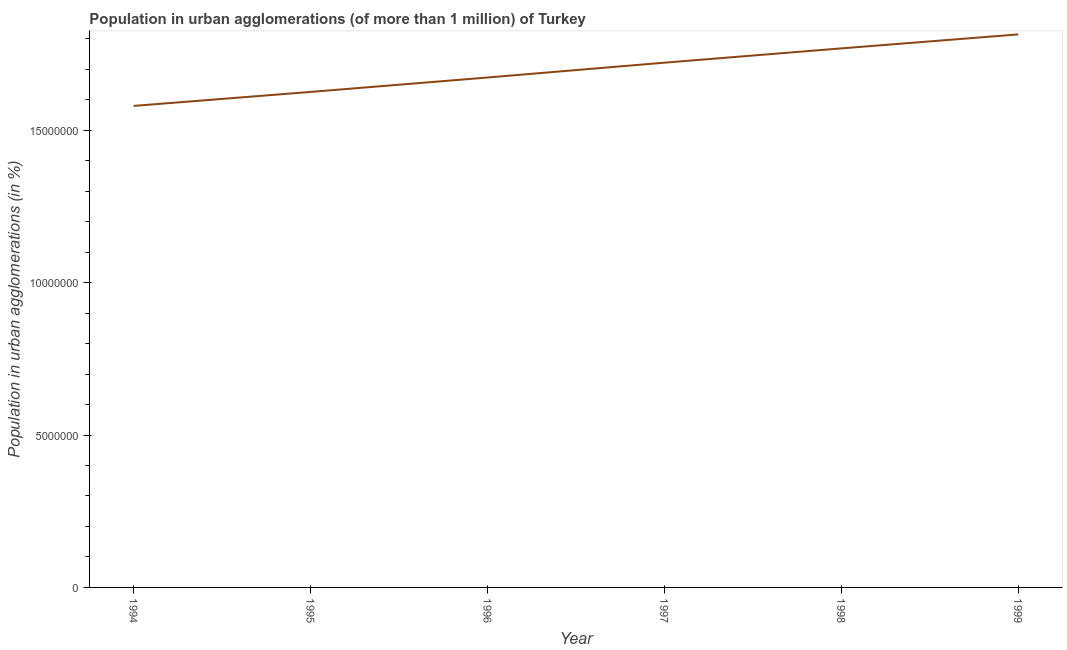What is the population in urban agglomerations in 1994?
Make the answer very short. 1.58e+07. Across all years, what is the maximum population in urban agglomerations?
Make the answer very short. 1.81e+07. Across all years, what is the minimum population in urban agglomerations?
Offer a very short reply. 1.58e+07. In which year was the population in urban agglomerations maximum?
Keep it short and to the point. 1999. What is the sum of the population in urban agglomerations?
Provide a succinct answer. 1.02e+08. What is the difference between the population in urban agglomerations in 1998 and 1999?
Your response must be concise. -4.59e+05. What is the average population in urban agglomerations per year?
Keep it short and to the point. 1.70e+07. What is the median population in urban agglomerations?
Provide a succinct answer. 1.70e+07. Do a majority of the years between 1999 and 1994 (inclusive) have population in urban agglomerations greater than 9000000 %?
Make the answer very short. Yes. What is the ratio of the population in urban agglomerations in 1997 to that in 1999?
Offer a terse response. 0.95. Is the difference between the population in urban agglomerations in 1995 and 1999 greater than the difference between any two years?
Give a very brief answer. No. What is the difference between the highest and the second highest population in urban agglomerations?
Give a very brief answer. 4.59e+05. Is the sum of the population in urban agglomerations in 1996 and 1998 greater than the maximum population in urban agglomerations across all years?
Make the answer very short. Yes. What is the difference between the highest and the lowest population in urban agglomerations?
Your answer should be compact. 2.35e+06. In how many years, is the population in urban agglomerations greater than the average population in urban agglomerations taken over all years?
Offer a very short reply. 3. Does the population in urban agglomerations monotonically increase over the years?
Offer a terse response. Yes. How many lines are there?
Your answer should be compact. 1. What is the difference between two consecutive major ticks on the Y-axis?
Give a very brief answer. 5.00e+06. Are the values on the major ticks of Y-axis written in scientific E-notation?
Ensure brevity in your answer.  No. Does the graph contain any zero values?
Keep it short and to the point. No. Does the graph contain grids?
Give a very brief answer. No. What is the title of the graph?
Give a very brief answer. Population in urban agglomerations (of more than 1 million) of Turkey. What is the label or title of the X-axis?
Give a very brief answer. Year. What is the label or title of the Y-axis?
Make the answer very short. Population in urban agglomerations (in %). What is the Population in urban agglomerations (in %) of 1994?
Ensure brevity in your answer.  1.58e+07. What is the Population in urban agglomerations (in %) of 1995?
Provide a succinct answer. 1.63e+07. What is the Population in urban agglomerations (in %) in 1996?
Your answer should be compact. 1.67e+07. What is the Population in urban agglomerations (in %) of 1997?
Provide a short and direct response. 1.72e+07. What is the Population in urban agglomerations (in %) of 1998?
Ensure brevity in your answer.  1.77e+07. What is the Population in urban agglomerations (in %) in 1999?
Ensure brevity in your answer.  1.81e+07. What is the difference between the Population in urban agglomerations (in %) in 1994 and 1995?
Keep it short and to the point. -4.59e+05. What is the difference between the Population in urban agglomerations (in %) in 1994 and 1996?
Ensure brevity in your answer.  -9.32e+05. What is the difference between the Population in urban agglomerations (in %) in 1994 and 1997?
Offer a very short reply. -1.42e+06. What is the difference between the Population in urban agglomerations (in %) in 1994 and 1998?
Provide a short and direct response. -1.89e+06. What is the difference between the Population in urban agglomerations (in %) in 1994 and 1999?
Keep it short and to the point. -2.35e+06. What is the difference between the Population in urban agglomerations (in %) in 1995 and 1996?
Your response must be concise. -4.73e+05. What is the difference between the Population in urban agglomerations (in %) in 1995 and 1997?
Provide a succinct answer. -9.60e+05. What is the difference between the Population in urban agglomerations (in %) in 1995 and 1998?
Provide a short and direct response. -1.43e+06. What is the difference between the Population in urban agglomerations (in %) in 1995 and 1999?
Your answer should be compact. -1.89e+06. What is the difference between the Population in urban agglomerations (in %) in 1996 and 1997?
Your response must be concise. -4.86e+05. What is the difference between the Population in urban agglomerations (in %) in 1996 and 1998?
Your answer should be compact. -9.55e+05. What is the difference between the Population in urban agglomerations (in %) in 1996 and 1999?
Offer a terse response. -1.41e+06. What is the difference between the Population in urban agglomerations (in %) in 1997 and 1998?
Offer a terse response. -4.69e+05. What is the difference between the Population in urban agglomerations (in %) in 1997 and 1999?
Offer a terse response. -9.28e+05. What is the difference between the Population in urban agglomerations (in %) in 1998 and 1999?
Your answer should be very brief. -4.59e+05. What is the ratio of the Population in urban agglomerations (in %) in 1994 to that in 1995?
Keep it short and to the point. 0.97. What is the ratio of the Population in urban agglomerations (in %) in 1994 to that in 1996?
Offer a very short reply. 0.94. What is the ratio of the Population in urban agglomerations (in %) in 1994 to that in 1997?
Provide a succinct answer. 0.92. What is the ratio of the Population in urban agglomerations (in %) in 1994 to that in 1998?
Your answer should be compact. 0.89. What is the ratio of the Population in urban agglomerations (in %) in 1994 to that in 1999?
Your response must be concise. 0.87. What is the ratio of the Population in urban agglomerations (in %) in 1995 to that in 1997?
Your answer should be compact. 0.94. What is the ratio of the Population in urban agglomerations (in %) in 1995 to that in 1998?
Your response must be concise. 0.92. What is the ratio of the Population in urban agglomerations (in %) in 1995 to that in 1999?
Keep it short and to the point. 0.9. What is the ratio of the Population in urban agglomerations (in %) in 1996 to that in 1997?
Offer a very short reply. 0.97. What is the ratio of the Population in urban agglomerations (in %) in 1996 to that in 1998?
Provide a succinct answer. 0.95. What is the ratio of the Population in urban agglomerations (in %) in 1996 to that in 1999?
Your answer should be very brief. 0.92. What is the ratio of the Population in urban agglomerations (in %) in 1997 to that in 1999?
Offer a very short reply. 0.95. 